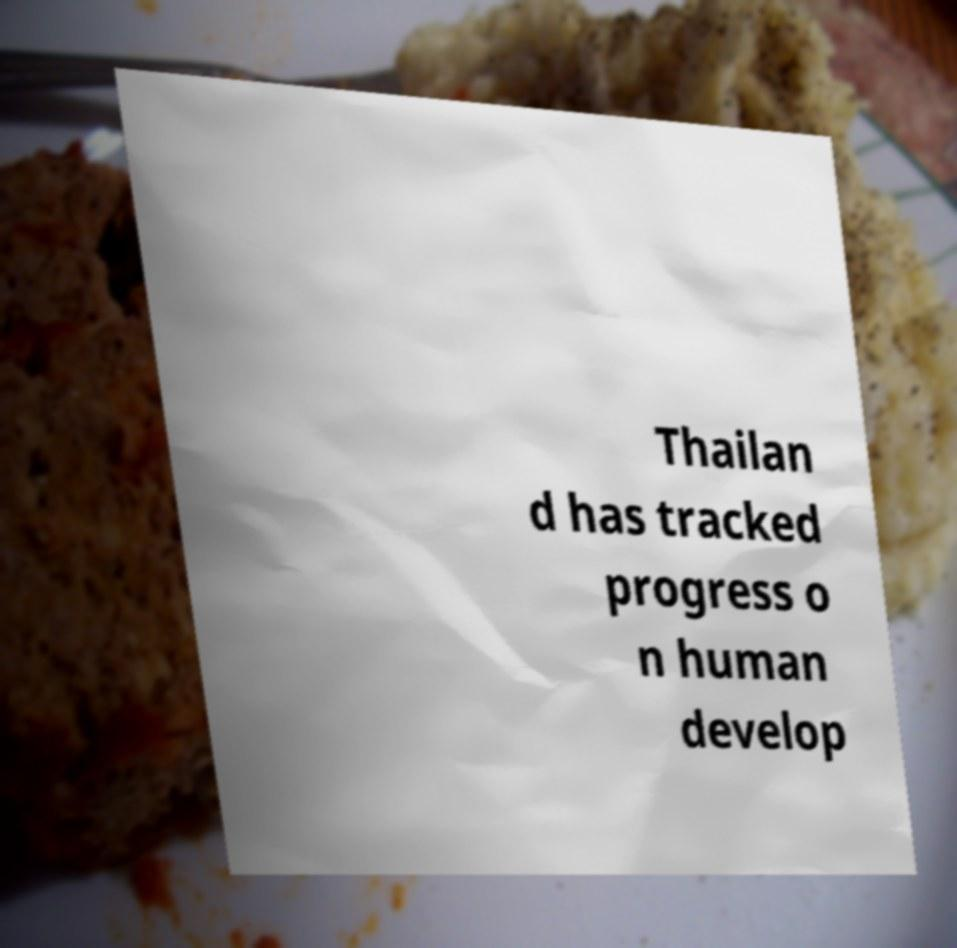Could you assist in decoding the text presented in this image and type it out clearly? Thailan d has tracked progress o n human develop 